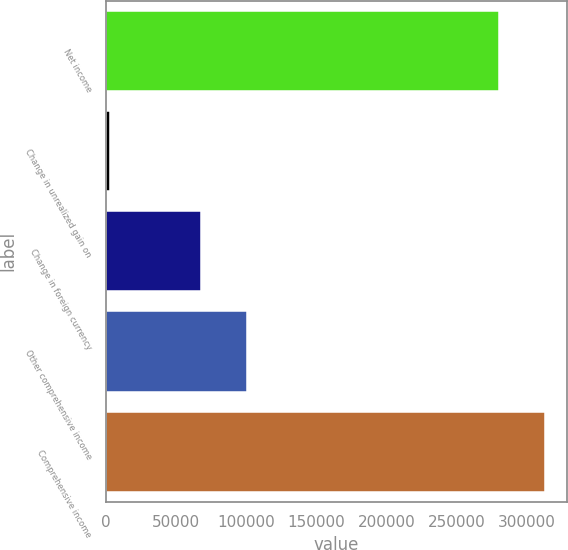<chart> <loc_0><loc_0><loc_500><loc_500><bar_chart><fcel>Net income<fcel>Change in unrealized gain on<fcel>Change in foreign currency<fcel>Other comprehensive income<fcel>Comprehensive income<nl><fcel>280275<fcel>3013<fcel>67861<fcel>100285<fcel>312699<nl></chart> 